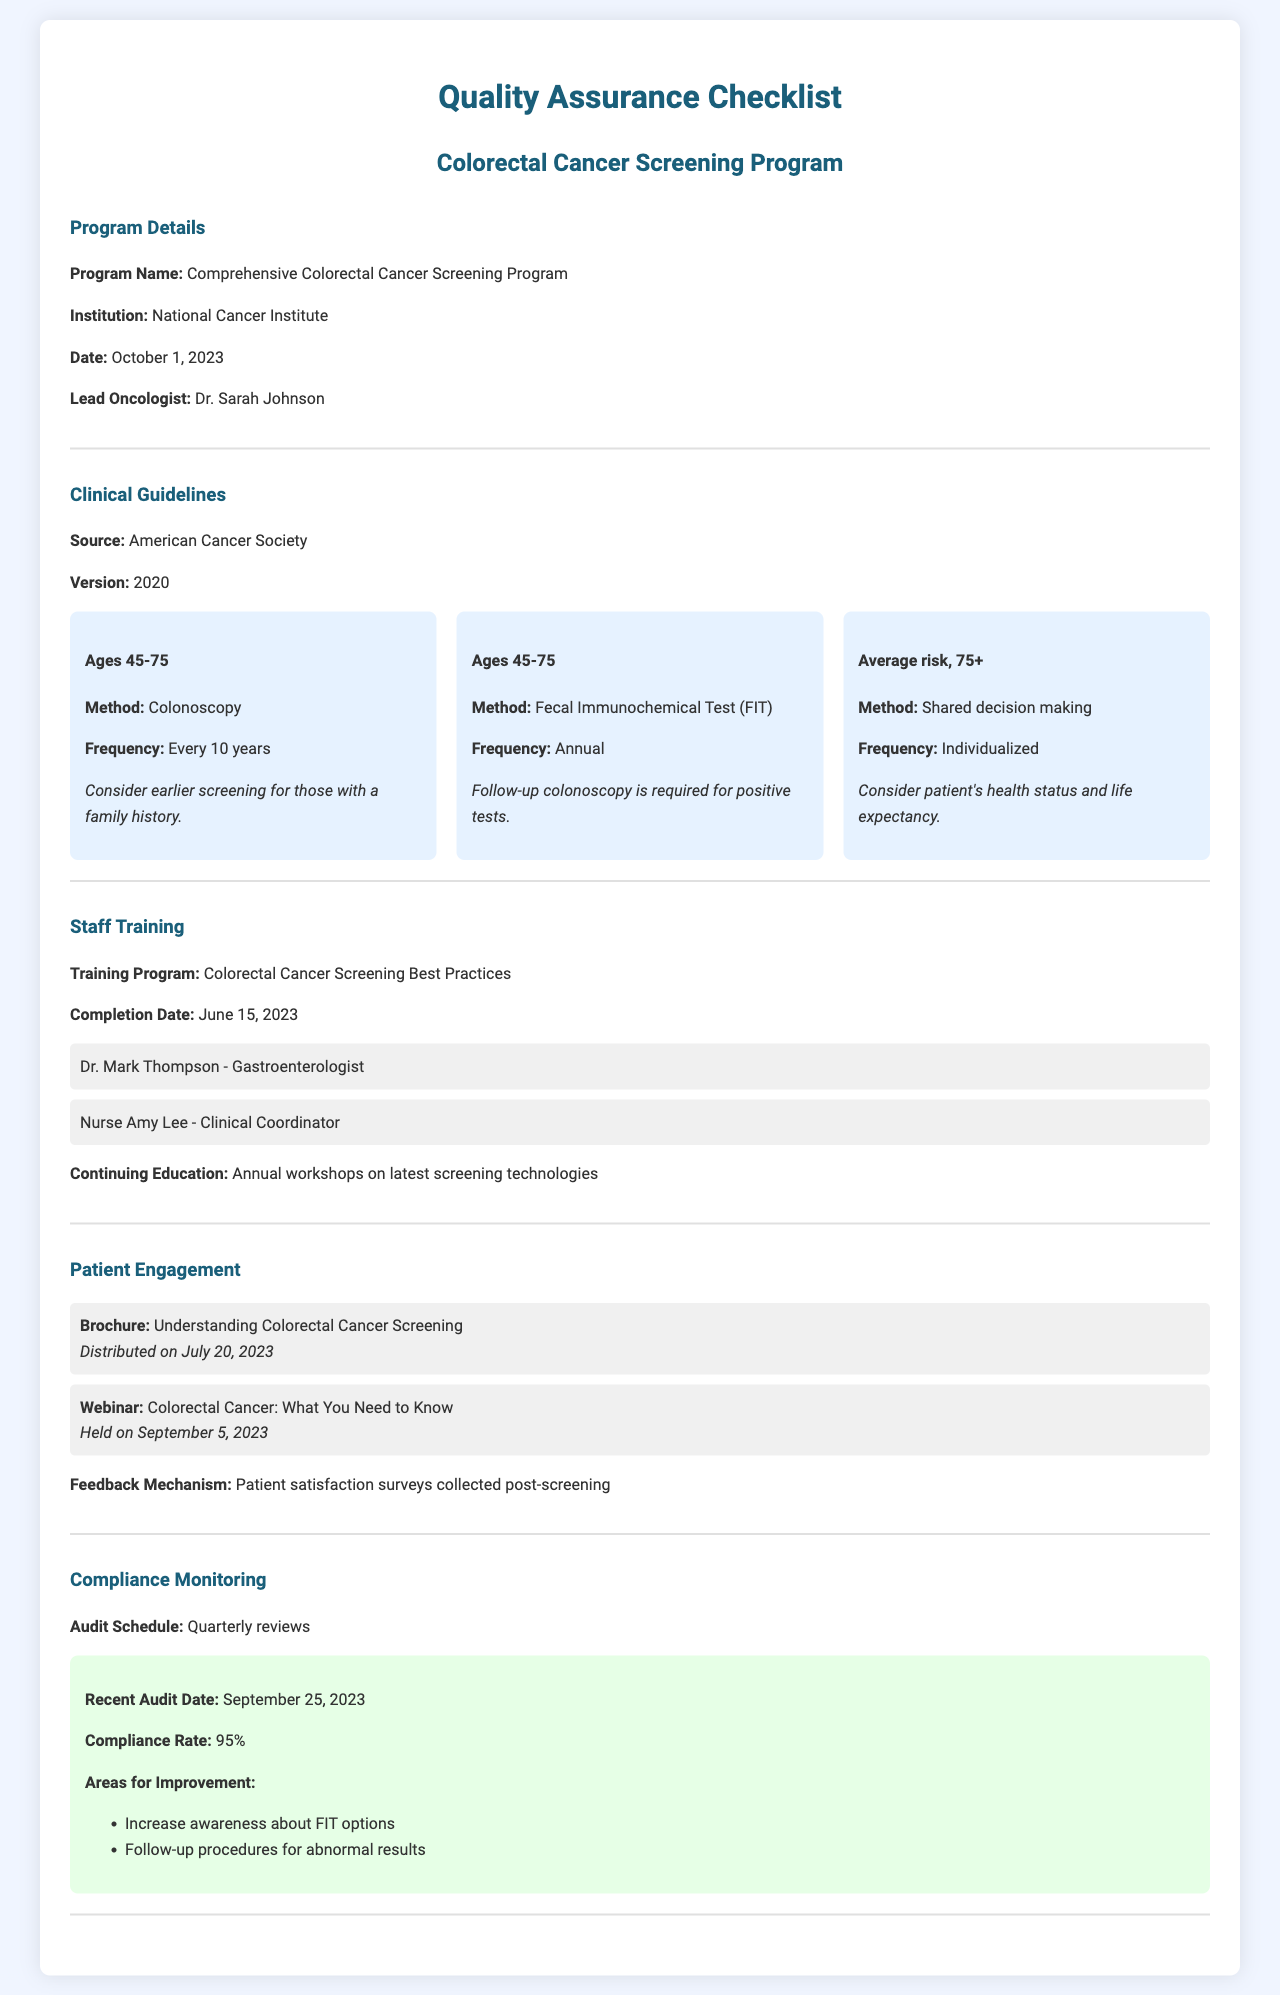what is the program name? The program name is mentioned in the document's section on Program Details.
Answer: Comprehensive Colorectal Cancer Screening Program who is the lead oncologist? The lead oncologist is specified in the Program Details section of the document.
Answer: Dr. Sarah Johnson what is the audit schedule for compliance monitoring? The audit schedule is noted in the Compliance Monitoring section of the document.
Answer: Quarterly reviews which organization provides the clinical guidelines? The organization that provides the clinical guidelines is indicated in the Clinical Guidelines section.
Answer: American Cancer Society when was the training program completed? The completion date for the training program is found in the Staff Training section.
Answer: June 15, 2023 what is the compliance rate reported in the recent audit? The compliance rate is listed in the Compliance Monitoring section of the document.
Answer: 95% what follow-up is required for positive FIT tests? The follow-up requirement for positive tests is outlined under Clinical Guidelines.
Answer: Follow-up colonoscopy is required what were the areas for improvement mentioned in the recent audit? The areas for improvement are detailed in the Compliance Monitoring section.
Answer: Increase awareness about FIT options, Follow-up procedures for abnormal results what is the frequency of colonoscopy for ages 45-75? The frequency for colonoscopy is stated in the Clinical Guidelines section.
Answer: Every 10 years 